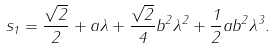<formula> <loc_0><loc_0><loc_500><loc_500>s _ { 1 } = \frac { \sqrt { 2 } } { 2 } + a \lambda + \frac { \sqrt { 2 } } { 4 } b ^ { 2 } \lambda ^ { 2 } + \frac { 1 } { 2 } a b ^ { 2 } \lambda ^ { 3 } .</formula> 